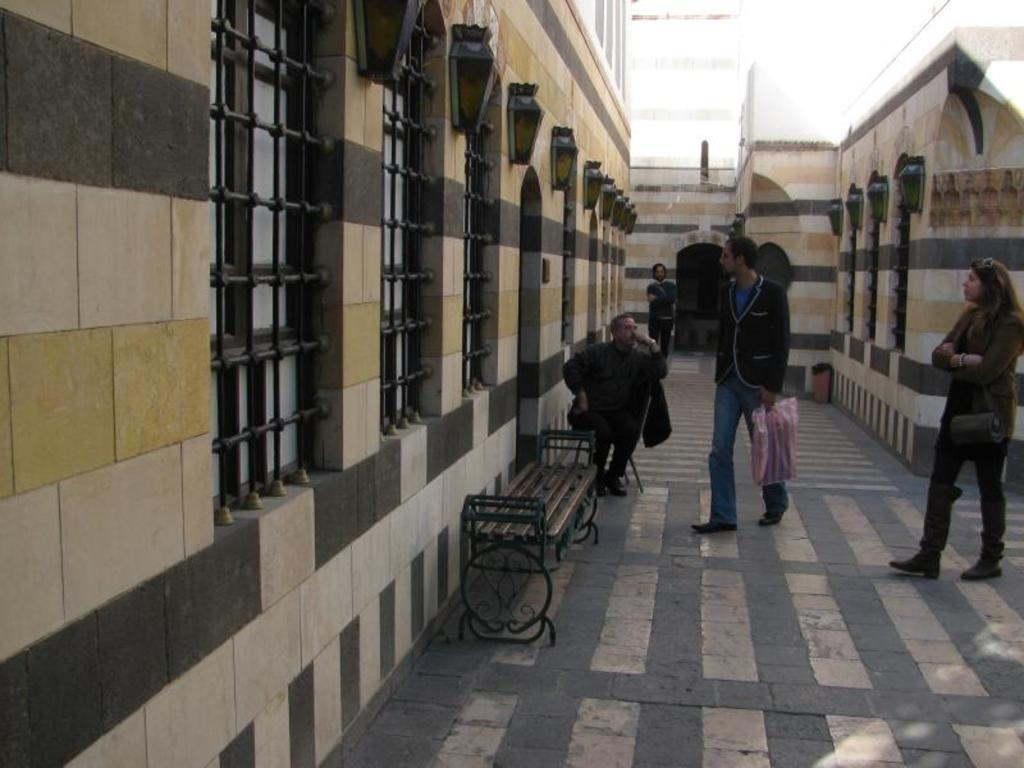How many people are in the image? There are four people in the image. Can you describe the gender of each person? Three of the people are men, and one is a woman. What are the positions or actions of the men in the image? One man is standing at the back, another man is walking towards a door, and the third man is sitting beside the door. What type of kite is the woman holding in the image? There is no kite present in the image; the woman is not holding any object. 